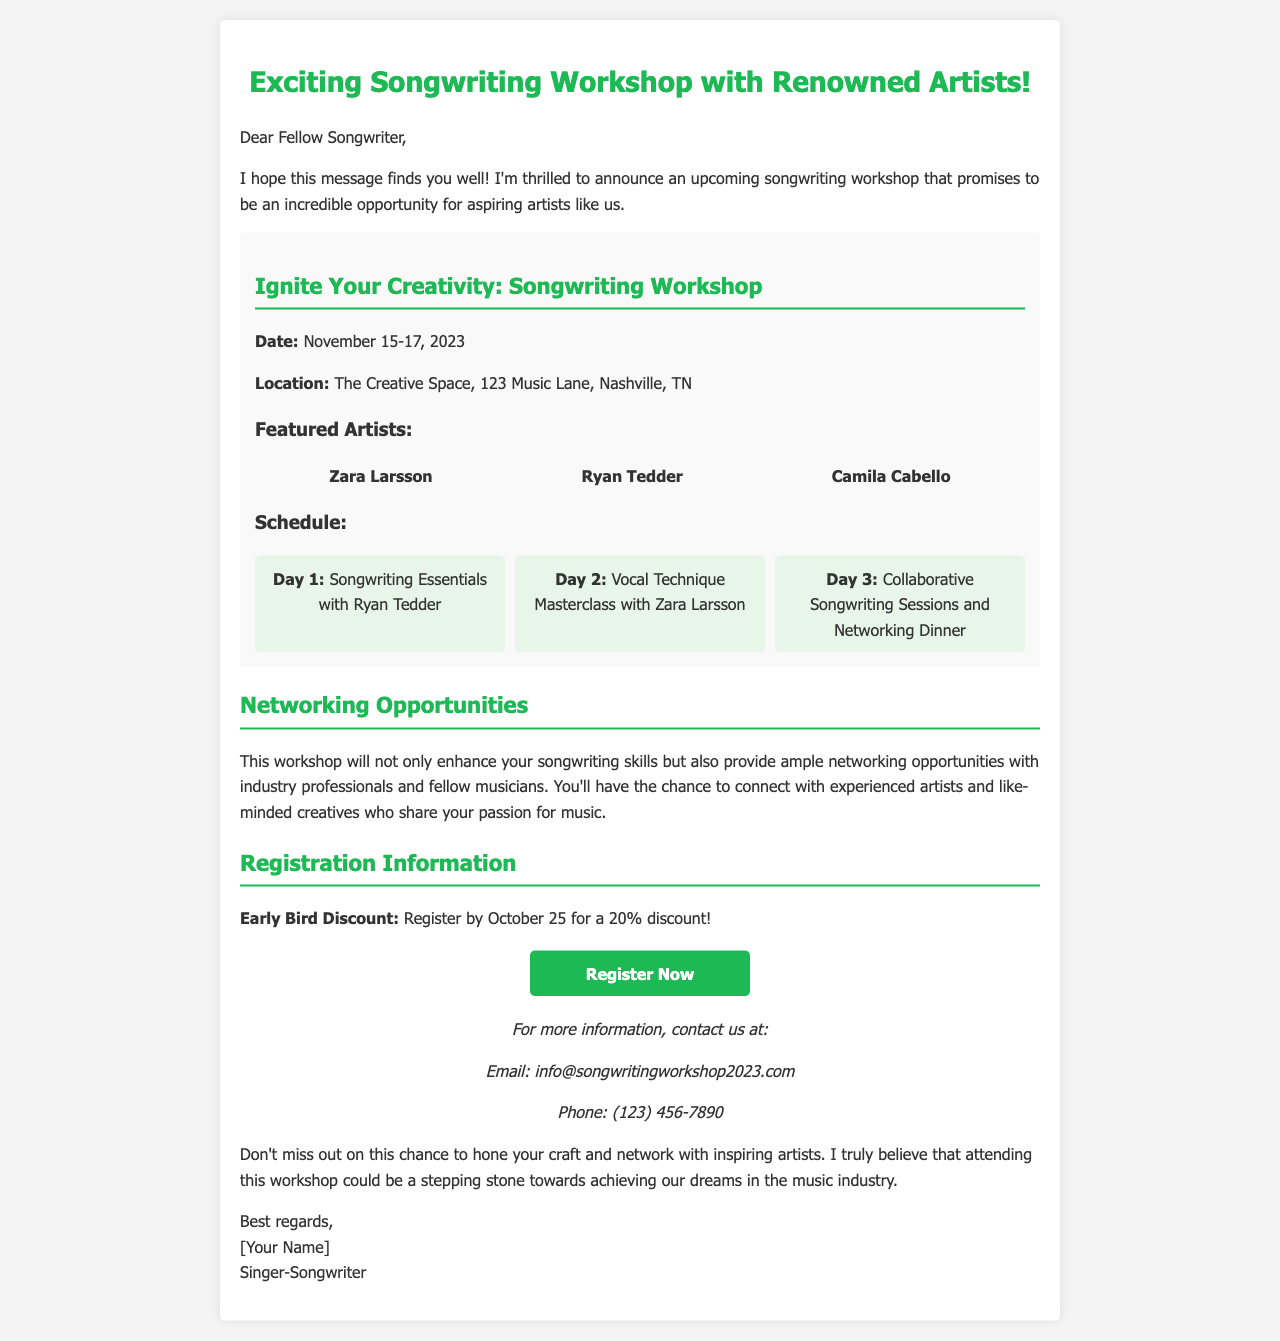what is the date of the workshop? The workshop is scheduled for November 15-17, 2023.
Answer: November 15-17, 2023 where is the workshop located? The workshop will take place at The Creative Space, 123 Music Lane, Nashville, TN.
Answer: The Creative Space, 123 Music Lane, Nashville, TN who is featured on Day 2 of the workshop? On Day 2, Zara Larsson will conduct the Vocal Technique Masterclass.
Answer: Zara Larsson what discount is offered for early registration? The early bird discount for registration is 20% if registered by October 25.
Answer: 20% what types of opportunities does the workshop provide? The workshop offers networking opportunities with industry professionals and fellow musicians.
Answer: Networking opportunities how many featured artists are mentioned in the document? There are three featured artists highlighted in the workshop details.
Answer: three what is included in Day 3 of the workshop schedule? Day 3 consists of Collaborative Songwriting Sessions and Networking Dinner.
Answer: Collaborative Songwriting Sessions and Networking Dinner what should attendees do to register for the workshop? Attendees can register by visiting the provided link in the document.
Answer: visit the provided link 